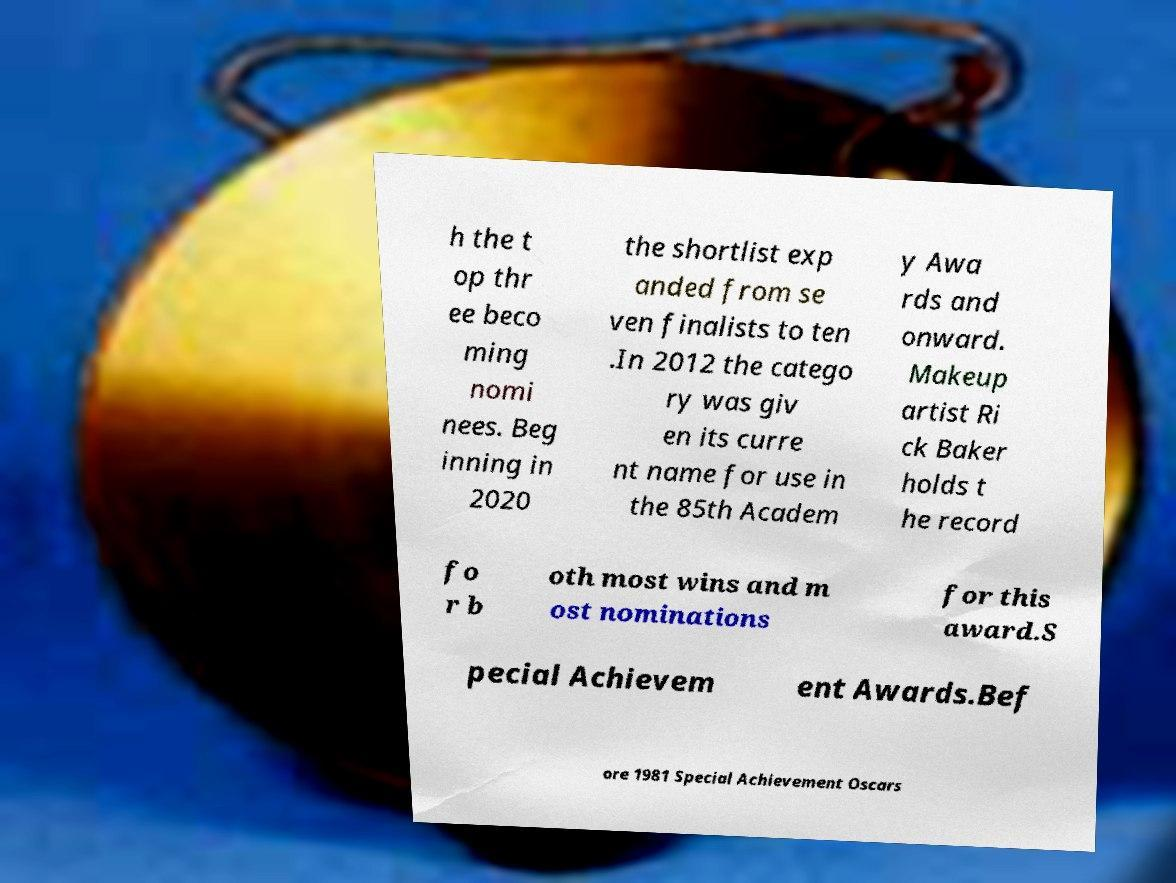Can you accurately transcribe the text from the provided image for me? h the t op thr ee beco ming nomi nees. Beg inning in 2020 the shortlist exp anded from se ven finalists to ten .In 2012 the catego ry was giv en its curre nt name for use in the 85th Academ y Awa rds and onward. Makeup artist Ri ck Baker holds t he record fo r b oth most wins and m ost nominations for this award.S pecial Achievem ent Awards.Bef ore 1981 Special Achievement Oscars 